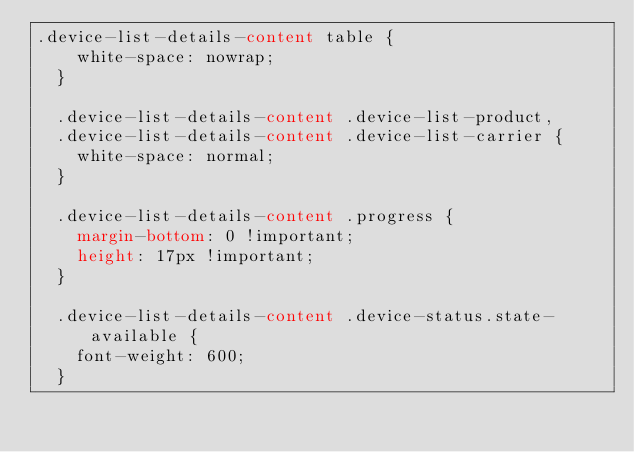Convert code to text. <code><loc_0><loc_0><loc_500><loc_500><_CSS_>.device-list-details-content table {
    white-space: nowrap;
  }
  
  .device-list-details-content .device-list-product,
  .device-list-details-content .device-list-carrier {
    white-space: normal;
  }
  
  .device-list-details-content .progress {
    margin-bottom: 0 !important;
    height: 17px !important;
  }
  
  .device-list-details-content .device-status.state-available {
    font-weight: 600;
  }
  </code> 